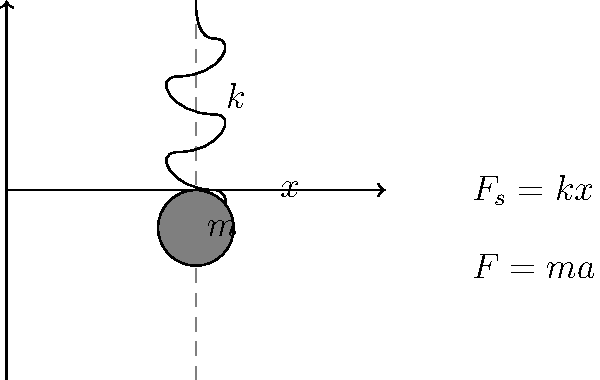Consider a spring-mass system as shown in the diagram. The mass $m$ is attached to a spring with stiffness $k$. Using the free-body diagram and equation of motion, derive an expression for the natural frequency of this system. How would you explain this concept to students in a way that makes it more accessible? To determine the natural frequency of the spring-mass system, we'll follow these steps:

1) First, let's consider the free-body diagram. The forces acting on the mass are:
   - The spring force: $F_s = kx$ (where $x$ is the displacement from equilibrium)
   - The inertial force: $F = ma$ (where $a$ is the acceleration)

2) According to Newton's Second Law, the sum of forces must equal zero:

   $F_s + F = 0$
   $kx + ma = 0$

3) We know that acceleration is the second derivative of displacement with respect to time:

   $a = \frac{d^2x}{dt^2}$

4) Substituting this into our equation:

   $kx + m\frac{d^2x}{dt^2} = 0$

5) Rearranging the equation:

   $m\frac{d^2x}{dt^2} + kx = 0$

6) This is the equation of motion for a simple harmonic oscillator. The general solution to this equation is:

   $x(t) = A\cos(\omega_n t) + B\sin(\omega_n t)$

   where $\omega_n$ is the natural frequency of the system.

7) If we substitute this solution back into our equation of motion and solve for $\omega_n$, we get:

   $\omega_n = \sqrt{\frac{k}{m}}$

8) The natural frequency in Hz is then:

   $f_n = \frac{\omega_n}{2\pi} = \frac{1}{2\pi}\sqrt{\frac{k}{m}}$

To make this concept more accessible to students:
- Use the analogy of a playground swing. The natural frequency is how fast the swing naturally moves back and forth without anyone pushing it.
- Demonstrate with a real spring and mass, showing how changing the mass or spring stiffness affects the oscillation speed.
- Use computer simulations to visualize how changing $k$ and $m$ affects the motion.
- Relate it to real-world applications like vehicle suspension systems or seismic design of buildings.
Answer: $f_n = \frac{1}{2\pi}\sqrt{\frac{k}{m}}$ 